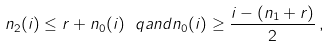<formula> <loc_0><loc_0><loc_500><loc_500>n _ { 2 } ( i ) \leq r + n _ { 0 } ( i ) \ q a n d n _ { 0 } ( i ) \geq \frac { i - ( n _ { 1 } + r ) } { 2 } \, ,</formula> 